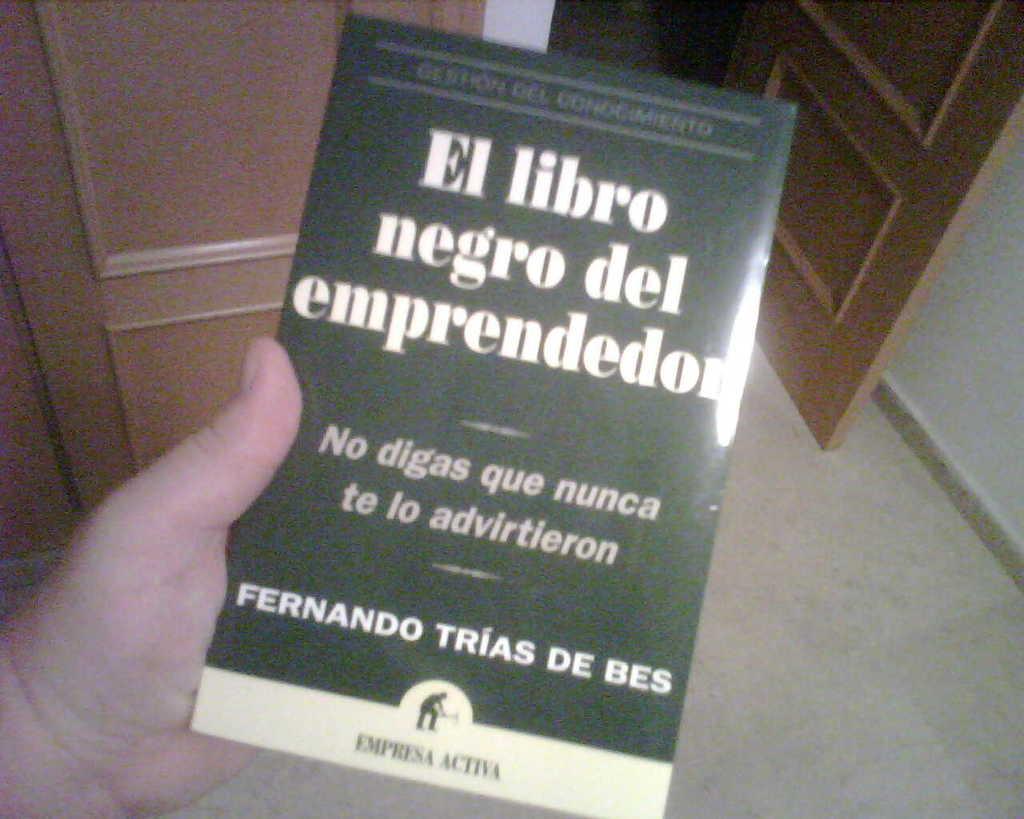Describe this image in one or two sentences. In this image, I can see a person's hand holding a book. These are the wooden doors. This is the floor. Here is the wall. 